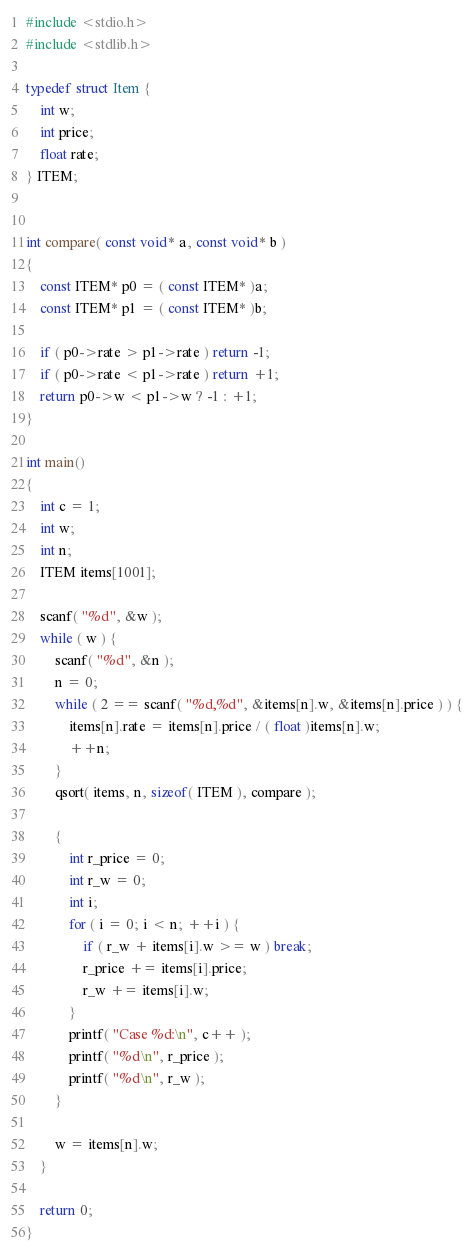Convert code to text. <code><loc_0><loc_0><loc_500><loc_500><_C_>#include <stdio.h>
#include <stdlib.h>

typedef struct Item {
	int w;
	int price;
	float rate;
} ITEM;


int compare( const void* a, const void* b )
{
	const ITEM* p0 = ( const ITEM* )a;
	const ITEM* p1 = ( const ITEM* )b;

	if ( p0->rate > p1->rate ) return -1;
	if ( p0->rate < p1->rate ) return +1;
	return p0->w < p1->w ? -1 : +1;
}

int main()
{
	int c = 1;
	int w;
	int n;
	ITEM items[1001];

	scanf( "%d", &w );
	while ( w ) {
		scanf( "%d", &n );
		n = 0;
		while ( 2 == scanf( "%d,%d", &items[n].w, &items[n].price ) ) {
			items[n].rate = items[n].price / ( float )items[n].w;
			++n;
		}
		qsort( items, n, sizeof( ITEM ), compare );

		{
			int r_price = 0;
			int r_w = 0;
			int i;
			for ( i = 0; i < n; ++i ) {
				if ( r_w + items[i].w >= w ) break;
				r_price += items[i].price;
				r_w += items[i].w;
			}
			printf( "Case %d:\n", c++ );
			printf( "%d\n", r_price );
			printf( "%d\n", r_w );
		}

		w = items[n].w;
	}

	return 0;
}</code> 